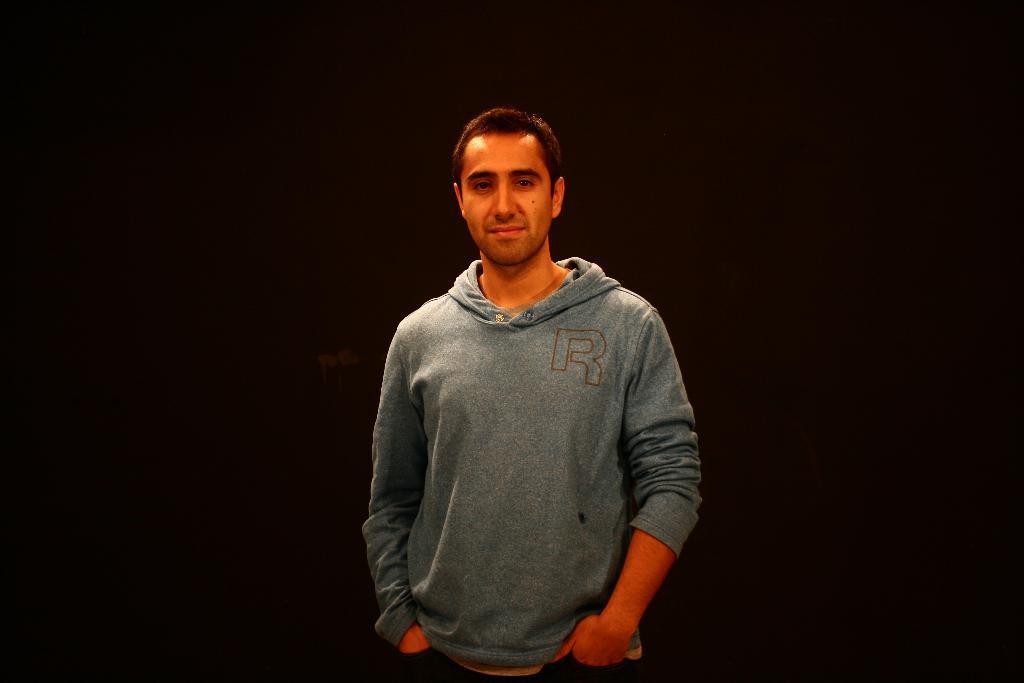Describe this image in one or two sentences. In this picture we can observe a person standing, wearing a grey color hoodie. He is smiling. The background is completely dark. 